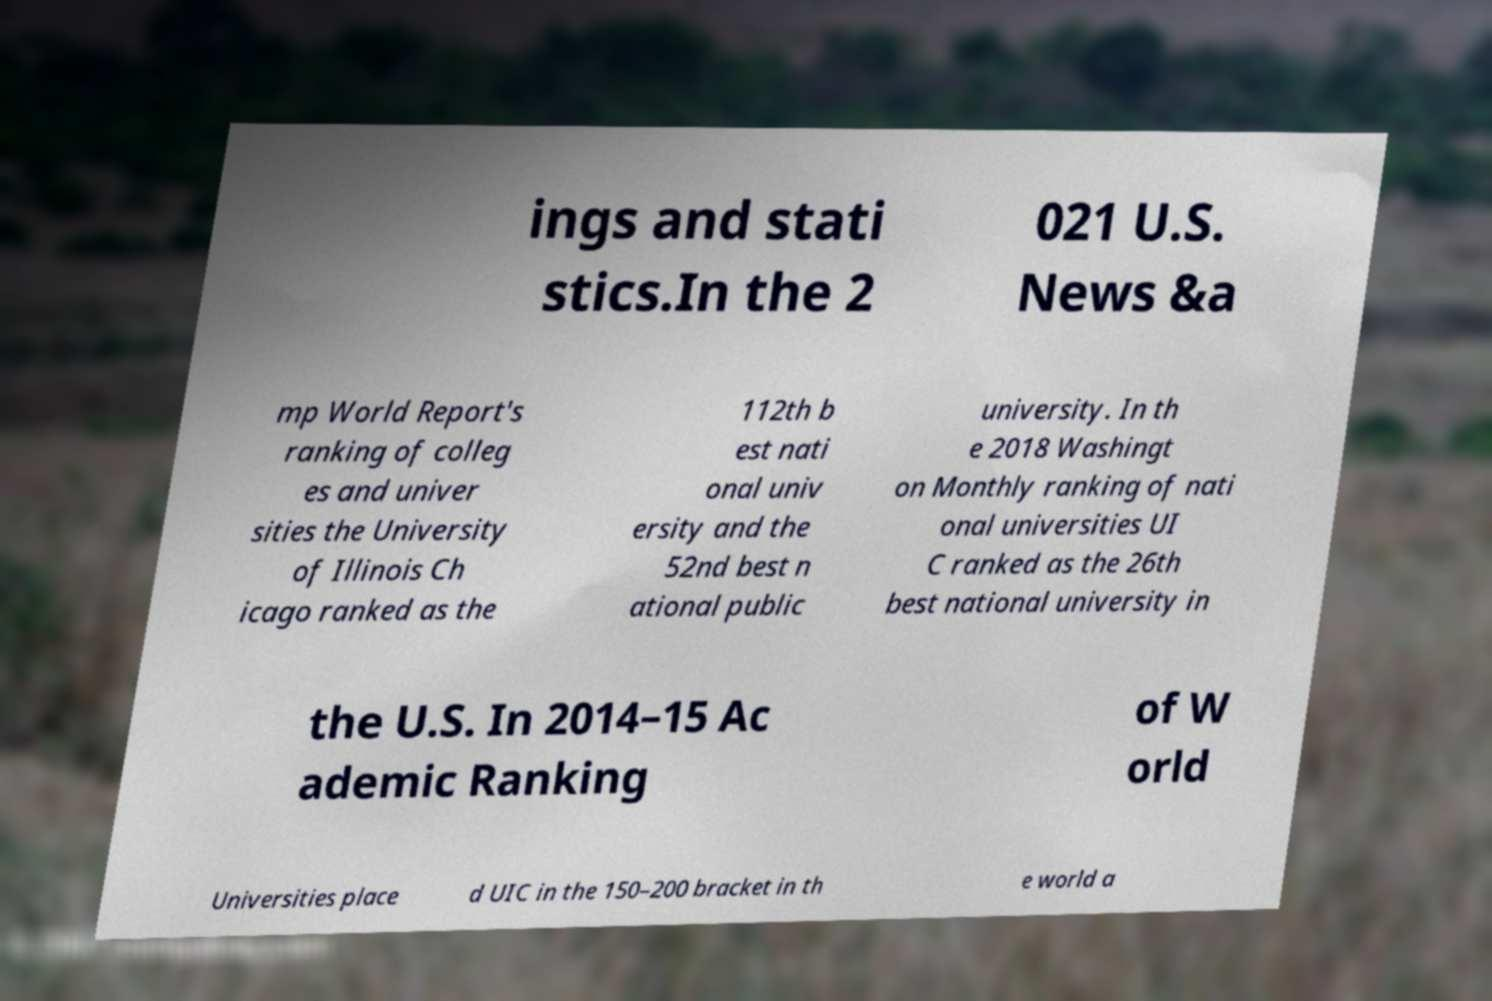Please read and relay the text visible in this image. What does it say? ings and stati stics.In the 2 021 U.S. News &a mp World Report's ranking of colleg es and univer sities the University of Illinois Ch icago ranked as the 112th b est nati onal univ ersity and the 52nd best n ational public university. In th e 2018 Washingt on Monthly ranking of nati onal universities UI C ranked as the 26th best national university in the U.S. In 2014–15 Ac ademic Ranking of W orld Universities place d UIC in the 150–200 bracket in th e world a 